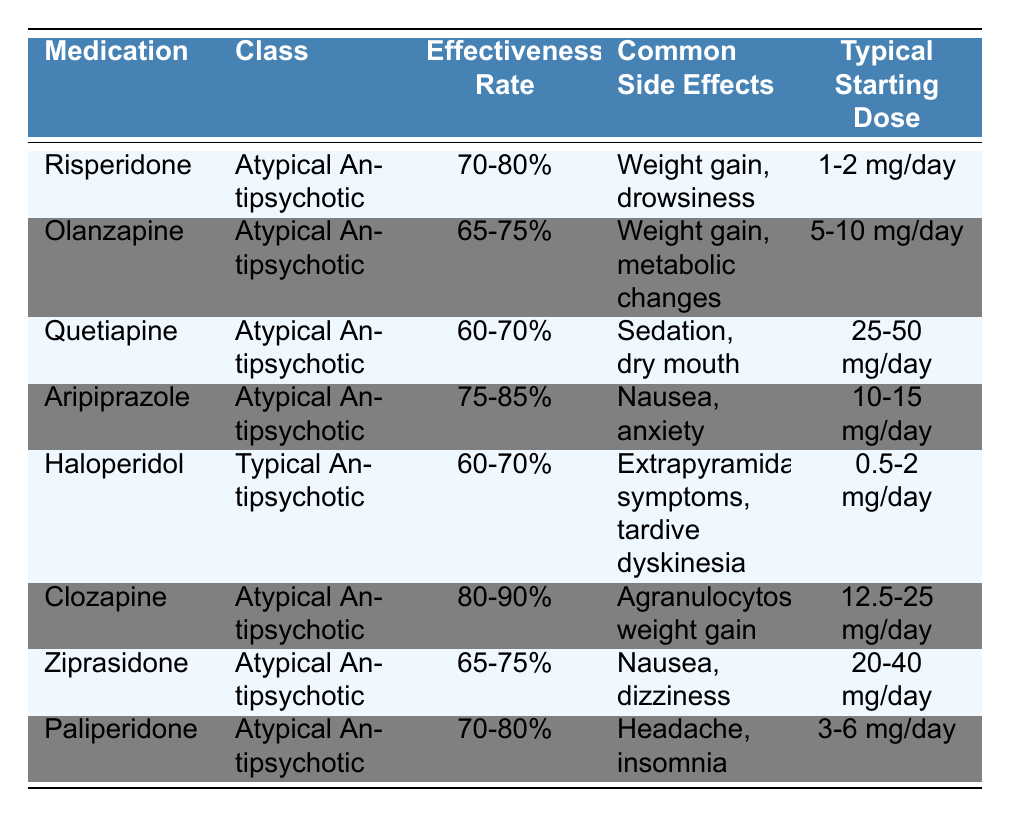What is the effectiveness rate of Clozapine? The table indicates the effectiveness rate of Clozapine specifically, which is listed in the "Effectiveness Rate" column. Clozapine has an effectiveness rate of 80-90%.
Answer: 80-90% Which medication has the highest effectiveness rate? To find the highest effectiveness rate, we can compare the rates listed in the table. Clozapine, with an effectiveness rate of 80-90%, is higher than the others.
Answer: Clozapine List one common side effect of Aripiprazole. The column for "Common Side Effects" provides information about side effects for each medication. For Aripiprazole, one common side effect mentioned is nausea.
Answer: Nausea Is the typical starting dose for Haloperidol lower than 3 mg per day? The table shows the typical starting dose for Haloperidol as ranging from 0.5 mg to 2 mg per day, which is less than 3 mg.
Answer: Yes What is the average effectiveness rate of the medications listed? The effectiveness rates for the medications are 70-80%, 65-75%, 60-70%, 75-85%, 60-70%, 80-90%, 65-75%, and 70-80%. To find the average, we can convert these ranges to midpoints and calculate their average: (75 + 70 + 65 + 80 + 65 + 85 + 70 + 75) / 8 yields an approximate average of 73.75%.
Answer: Approximately 73.75% Which medication class has the highest individual effectiveness rate? We can analyze the effectiveness rates any Atypical Antipsychotics and Typical Antipsychotics. Clozapine has the highest effectiveness rate of 80-90%, and it belongs to the Atypical Antipsychotic class. The maximum in Typical Antipsychotic is 70%, which is lower than Clozapine's, confirming that Atypical Antipsychotics have the highest rate overall.
Answer: Atypical Antipsychotics What are the common side effects of Paliperidone? The common side effects of Paliperidone can be directly taken from the table's "Common Side Effects" column, which lists headache and insomnia.
Answer: Headache, insomnia Are all the medications in the table classified as Atypical Antipsychotics? The table contains both Atypical Antipsychotic medications and one Typical Antipsychotic (Haloperidol). Therefore, not all medications are classified as Atypical Antipsychotics.
Answer: No What is the typical starting dose range for Olanzapine? The typical starting dose for Olanzapine is provided in the "Typical Starting Dose" column, which lists the range as 5-10 mg per day.
Answer: 5-10 mg/day Which medication has the lowest effectiveness rate and what is it? By reviewing the effectiveness rates in the table, Quetiapine and Haloperidol both share a lower effectiveness rate of 60-70%. Since they are the lowest, we can mention Quetiapine as it appears first in the list.
Answer: Quetiapine, 60-70% 